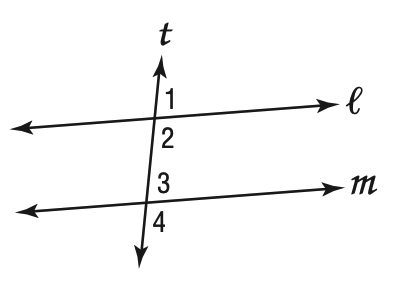Answer the mathemtical geometry problem and directly provide the correct option letter.
Question: In the figure at the right, which cannot be true if m \parallel l and m \angle 1 = 73?
Choices: A: \angle 1 \cong \angle 4 B: \angle 3 \cong \angle 1 C: m \angle 2 + m \angle 3 = 180 D: m \angle 4 > 73 A 